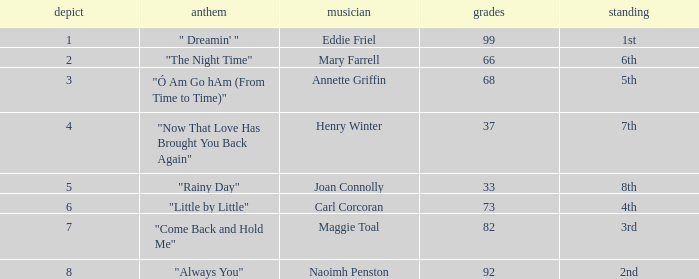What are the least points when the standing is 1st? 99.0. 